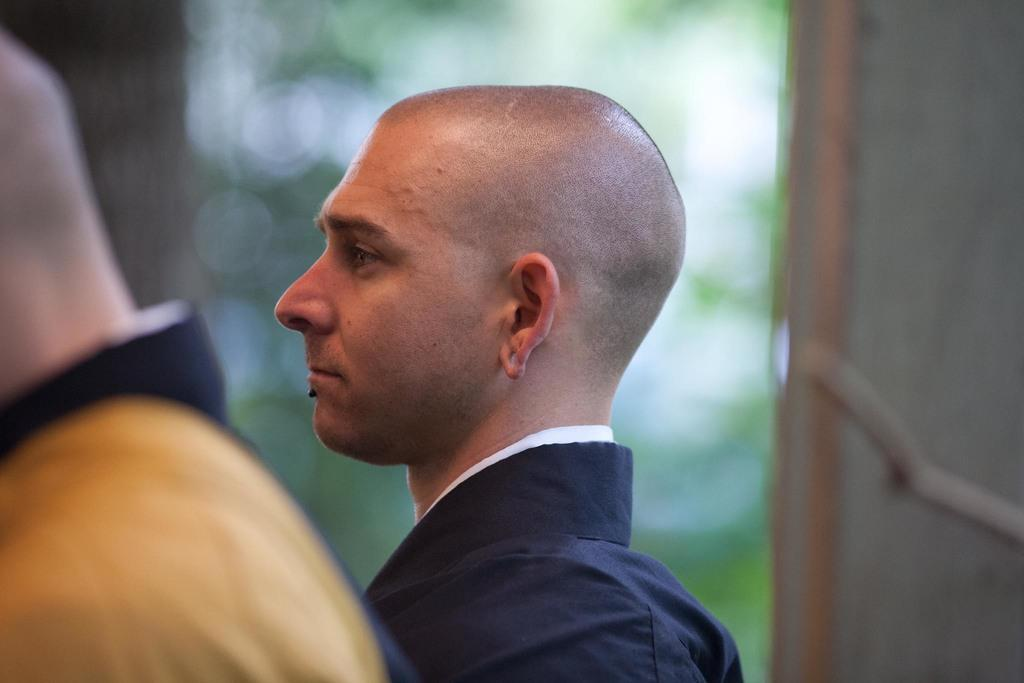How many people are present in the image? There are two people in the image. Can you describe the background of the image? The background appears blurry, and it may be a wall. What is the weekly profit of the screw in the image? There is no screw present in the image, and therefore no information about its weekly profit can be provided. 